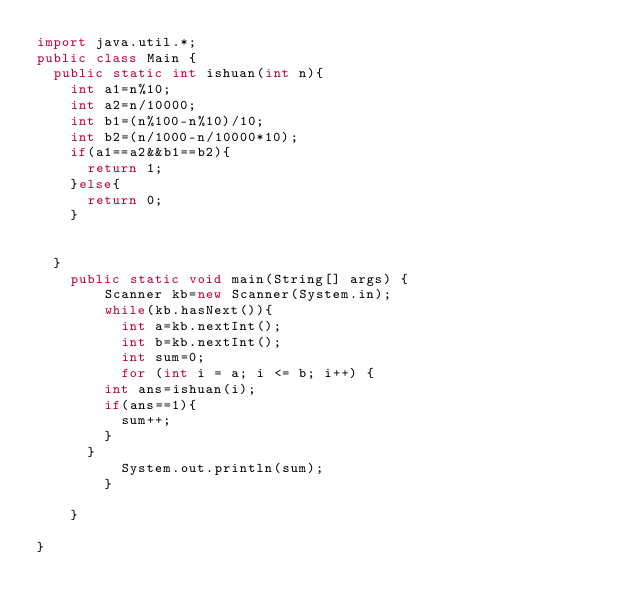Convert code to text. <code><loc_0><loc_0><loc_500><loc_500><_Java_>import java.util.*;
public class Main {
	public static int ishuan(int n){
		int a1=n%10;
		int a2=n/10000;
		int b1=(n%100-n%10)/10;
		int b2=(n/1000-n/10000*10);
		if(a1==a2&&b1==b2){
			return 1;
		}else{
			return 0;
		}
		
		
	}
    public static void main(String[] args) {
        Scanner kb=new Scanner(System.in);
        while(kb.hasNext()){
        	int a=kb.nextInt();
        	int b=kb.nextInt();  
        	int sum=0;
        	for (int i = a; i <= b; i++) {
				int ans=ishuan(i);
				if(ans==1){
					sum++;
				}
			}
        	System.out.println(sum);
        }
              
    }

}</code> 